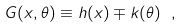<formula> <loc_0><loc_0><loc_500><loc_500>G ( x , \theta ) \equiv h ( x ) \mp k ( \theta ) \ ,</formula> 